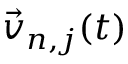Convert formula to latex. <formula><loc_0><loc_0><loc_500><loc_500>\vec { v } _ { n , j } ( t )</formula> 